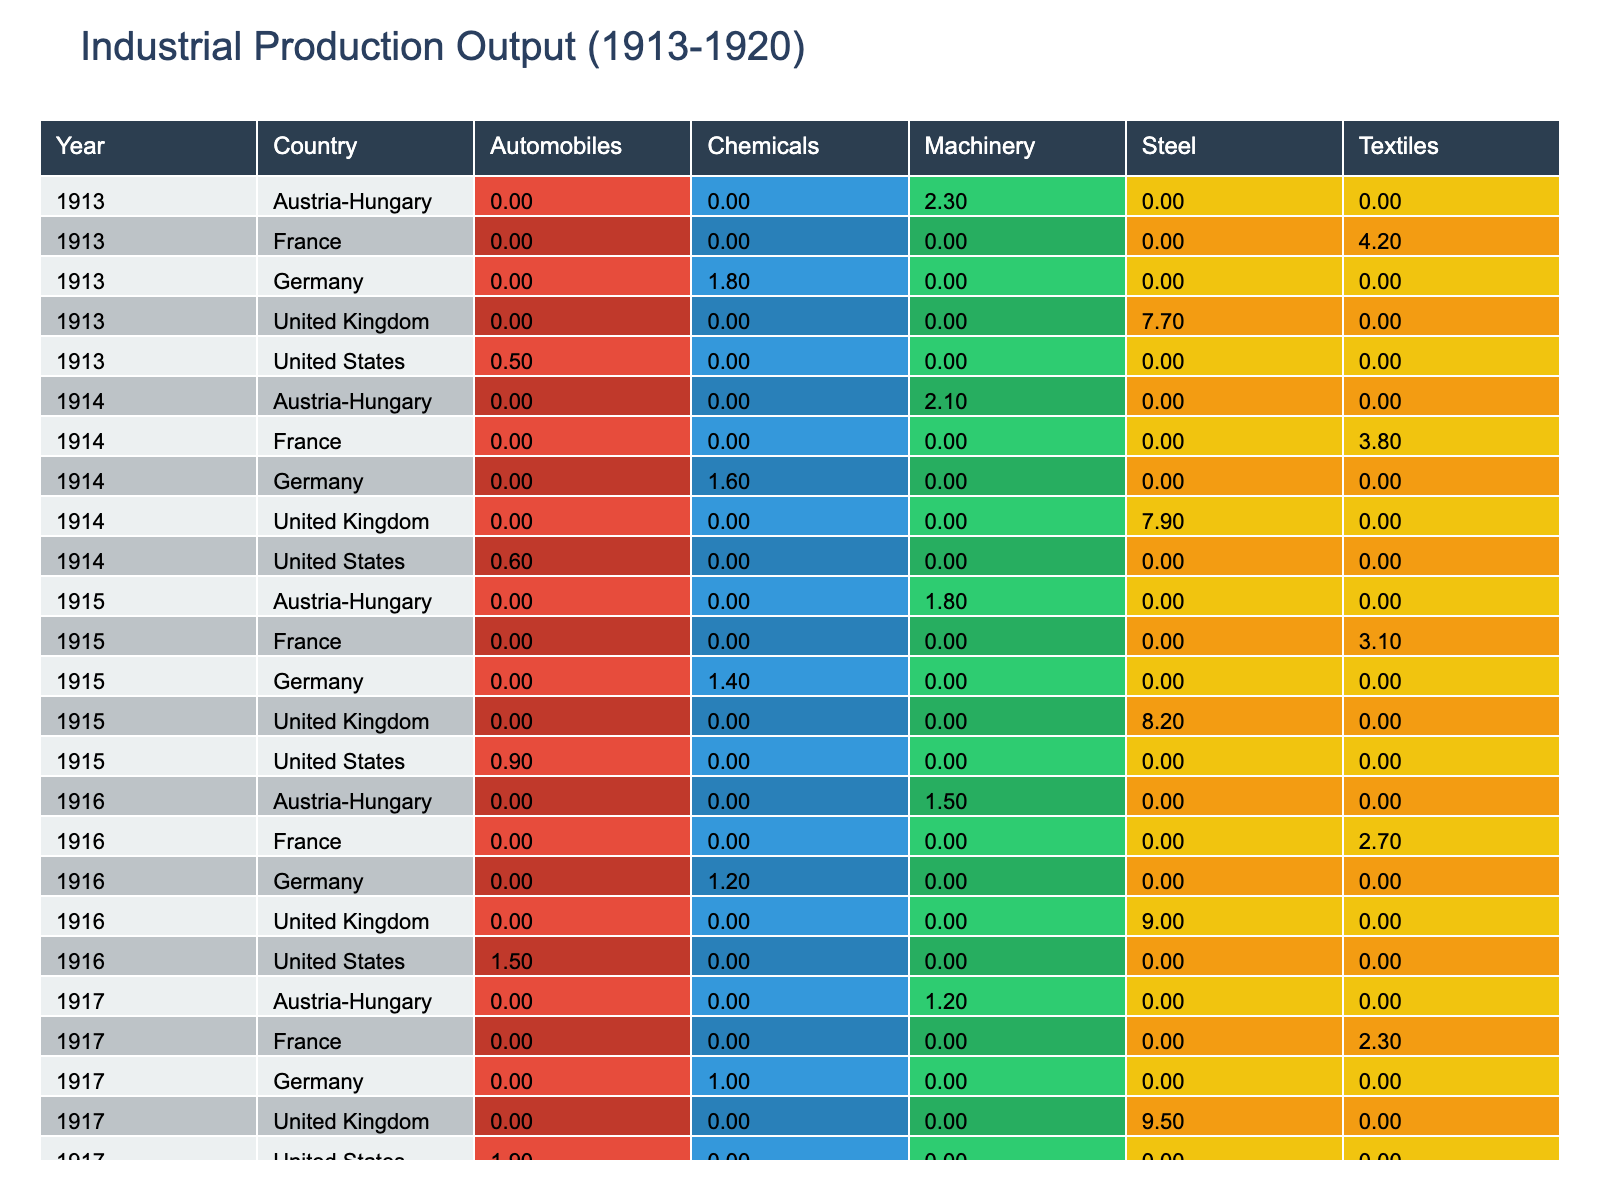What was the highest production output in the United Kingdom during the years listed? The highest production output in the United Kingdom according to the table is from the year 1918, with a steel production output of 9.7 million units. I determined this by checking each year for the United Kingdom and identifying the maximum value.
Answer: 9.7 million units What industry had the lowest production output in Germany during the years listed? In Germany, the industry with the lowest production output over the years listed is chemicals, which had a peak output of 1.8 million units in 1913 but gradually decreased to 0.7 million units by 1919. I identified this by comparing the production outputs for all industries in Germany across the years.
Answer: Chemicals In which year did the United States have the highest production output for automobiles? The United States had the highest production output for automobiles in the year 1920, with an output of 2.2 million units. I looked through the table to compare the outputs for each year and industry.
Answer: 1920 Calculate the total production output of textiles in France from 1913 to 1920. The total production output of textiles in France from 1913 to 1920 can be calculated by adding the outputs from each year: 4.2 (1913) + 3.8 (1914) + 3.1 (1915) + 2.7 (1916) + 2.3 (1917) + 2.0 (1918) + 2.5 (1919) + 3.0 (1920) = 23.6 million units. I summed all values across the years listed only for the textiles industry.
Answer: 23.6 million units Did Austria-Hungary's machinery production output ever exceed 2 million units during the years listed? No, Austria-Hungary never recorded a machinery production output exceeding 2 million units. The highest output was 2.3 million units in 1913, but it decreased in the following years, not surpassing that figure afterward. I evaluated each year's output for Austria-Hungary specifically for machinery.
Answer: No 